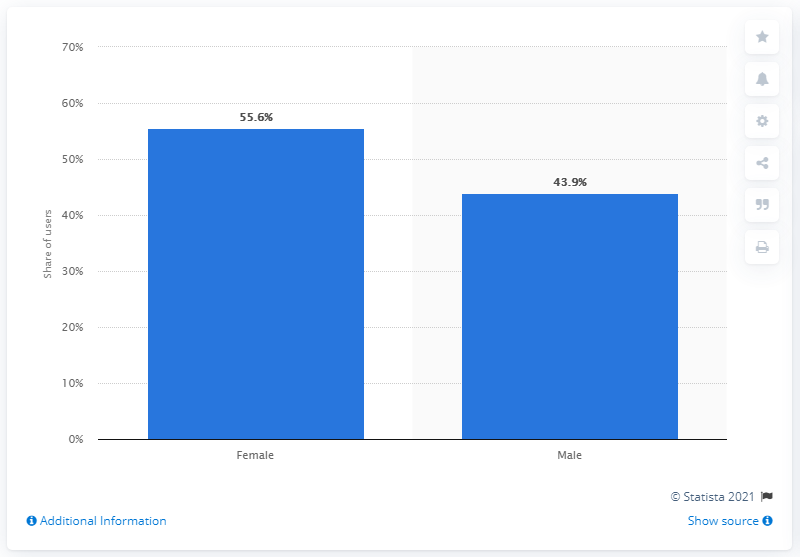Draw attention to some important aspects in this diagram. As of January 2021, it was reported that 43.9% of Snapchat users were male. 